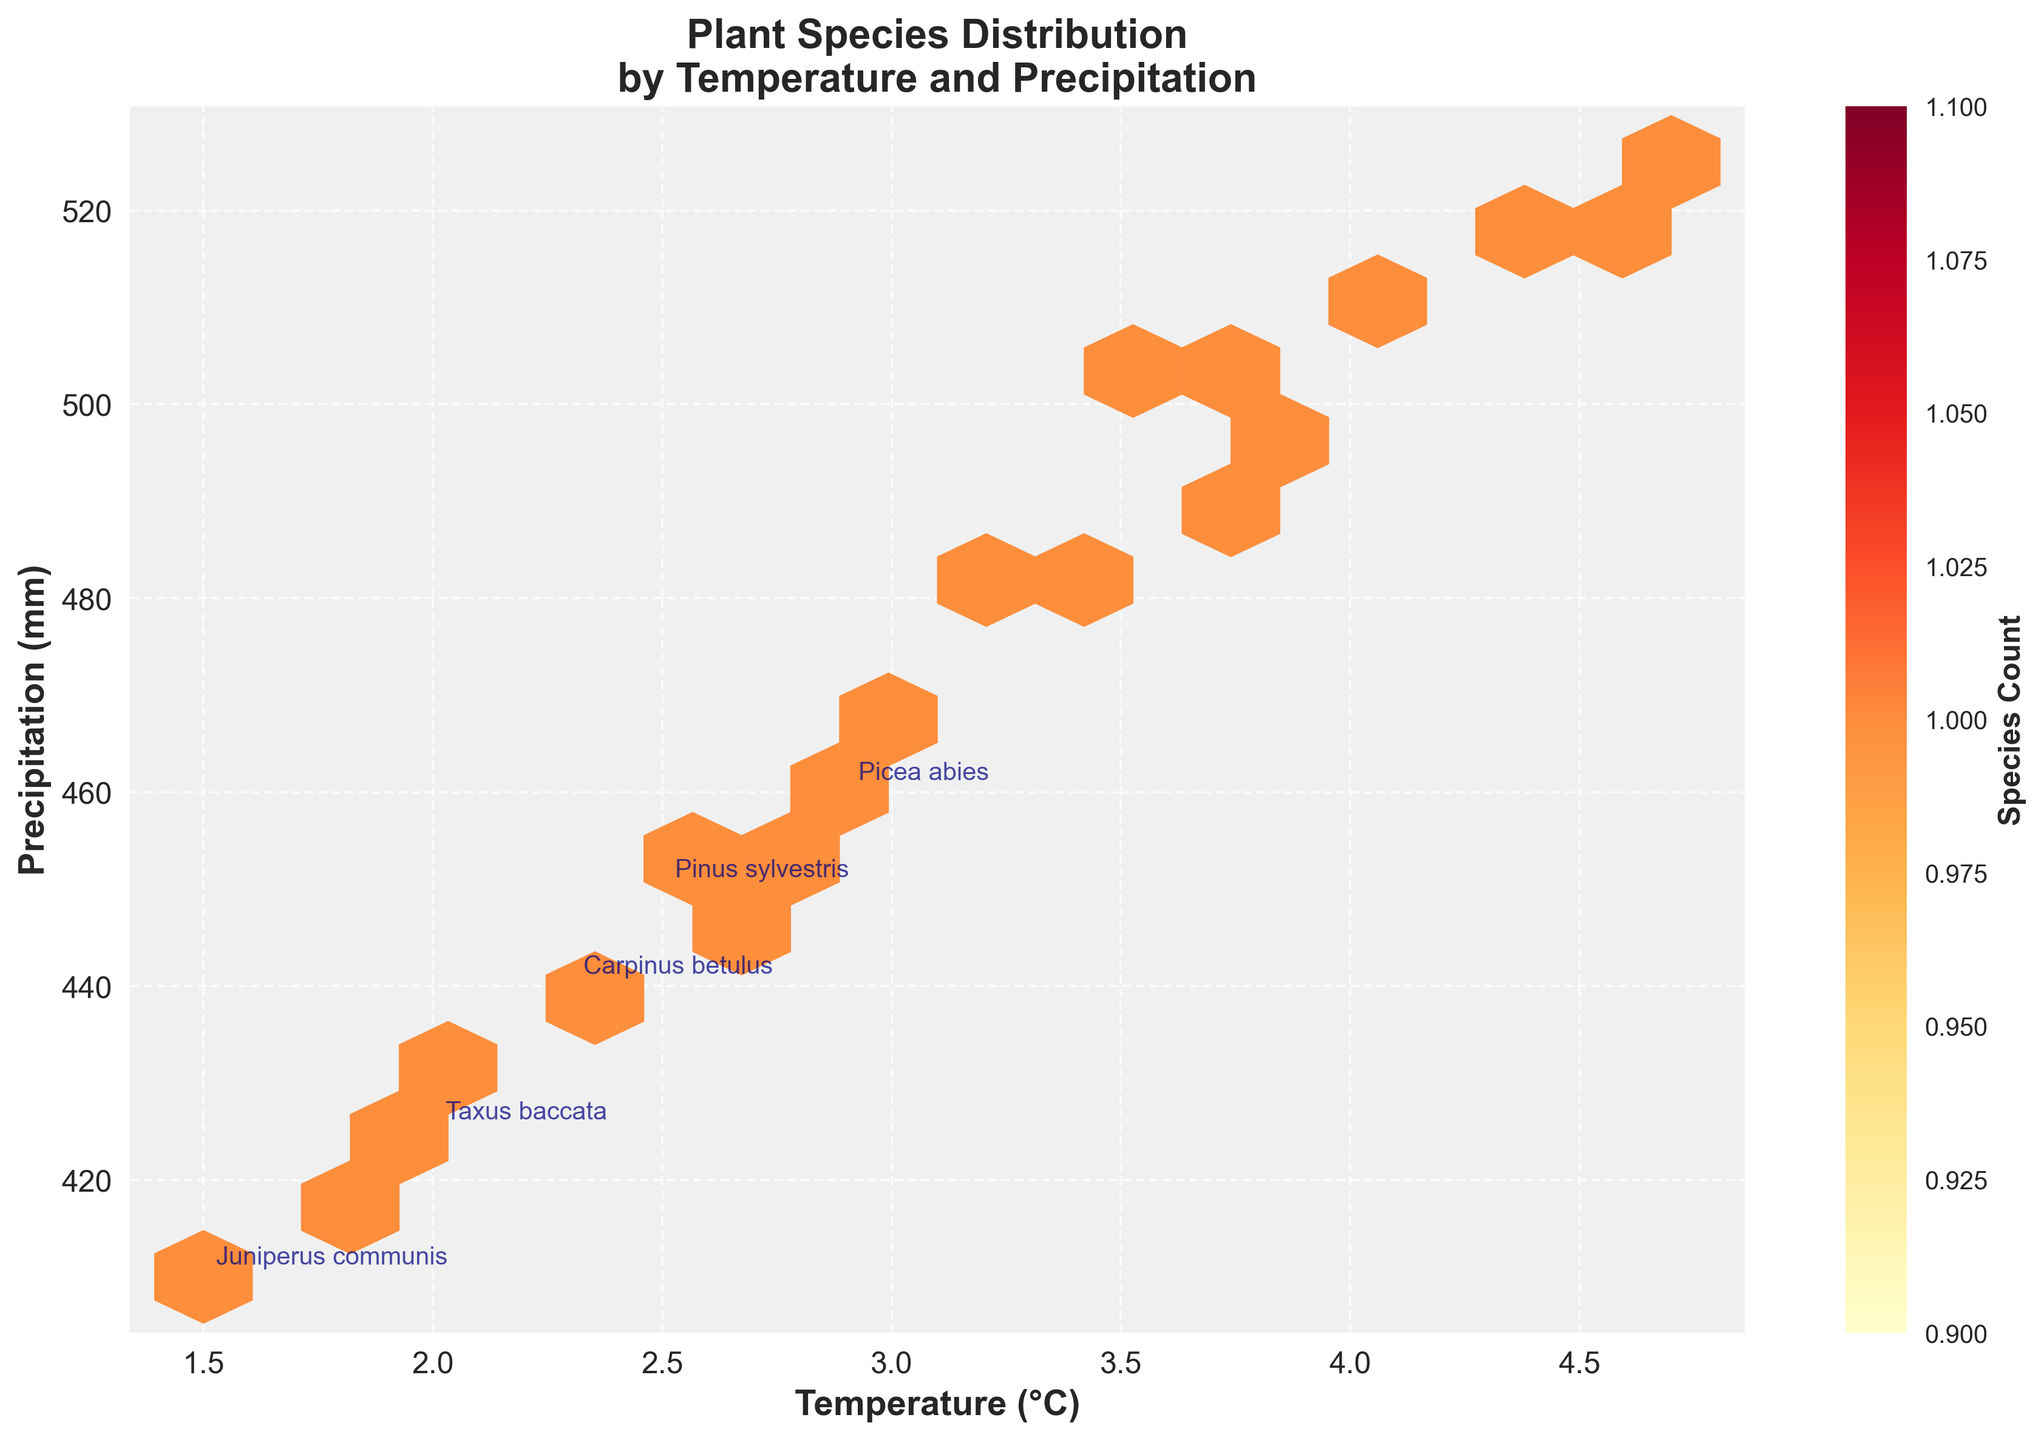How many hexagonal bins are present in the plot? Count the individual hexagons displayed in the plot.
Answer: 15 What is the title of the plot? Check the text at the top of the plot.
Answer: Plant Species Distribution by Temperature and Precipitation What are the x and y-axis labels? Follow the labels on both axes.
Answer: Temperature (°C), Precipitation (mm) Which bin has the highest species count based on color intensity? Look for the darkest hexagonal bin.
Answer: The bin around (4.0, 510 mm) appears dark with high species count What range of temperature and precipitation does the plot cover? Identify the range of values on the x-axis and y-axis.
Answer: 1.5 to 4.7 °C and 410 to 525 mm How many species were analyzed in this plot? Count the total number of data points, each representing a species.
Answer: 20 Which temperature and precipitation combination has the highest density of species? Identify the bin with the highest count and its approximate coordinates.
Answer: Around 4.0 °C and 510 mm Are there more species in the higher or lower temperature range? Compare the density of bins in the higher and lower segments of the temperature axis.
Answer: Higher temperature range Do species with higher precipitation values also have higher temperatures? Analyze if the bins with higher precipitation also correspond to higher temperatures.
Answer: Generally, yes What color represents the lowest species count on the plot? Refer to the color legend and observe the color associated with the lowest count.
Answer: Light yellow 